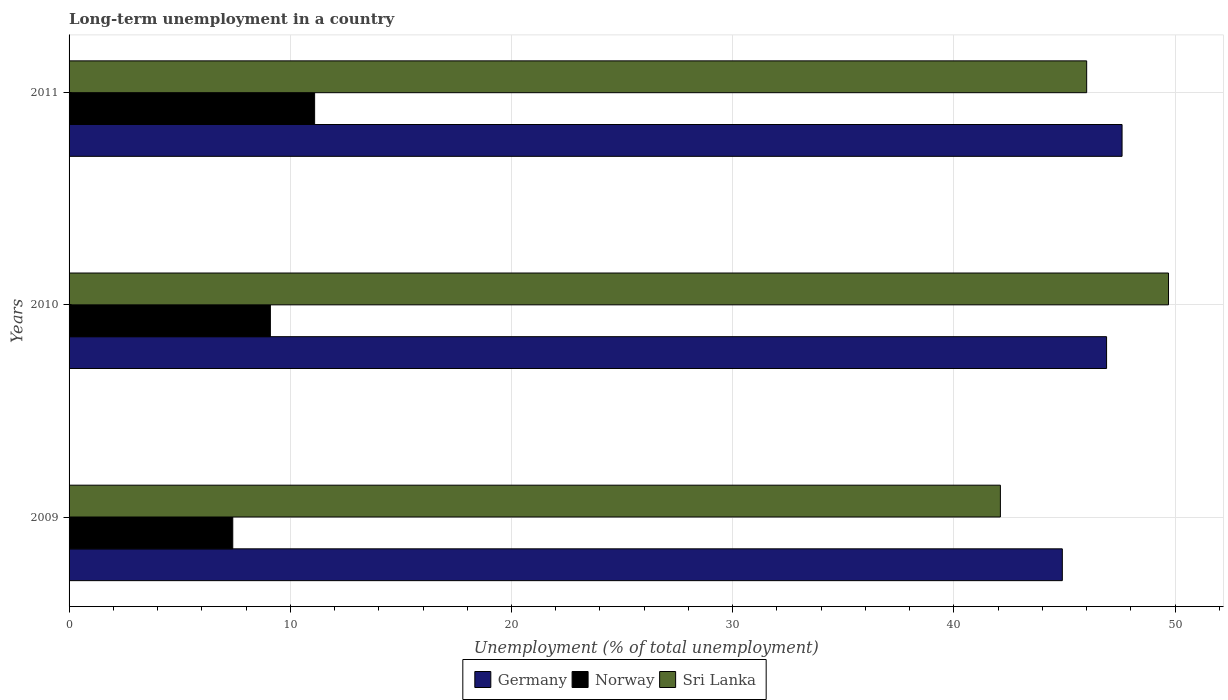How many groups of bars are there?
Provide a short and direct response. 3. Are the number of bars per tick equal to the number of legend labels?
Offer a terse response. Yes. Are the number of bars on each tick of the Y-axis equal?
Keep it short and to the point. Yes. How many bars are there on the 2nd tick from the top?
Keep it short and to the point. 3. How many bars are there on the 1st tick from the bottom?
Your response must be concise. 3. What is the label of the 1st group of bars from the top?
Provide a succinct answer. 2011. In how many cases, is the number of bars for a given year not equal to the number of legend labels?
Ensure brevity in your answer.  0. What is the percentage of long-term unemployed population in Germany in 2009?
Make the answer very short. 44.9. Across all years, what is the maximum percentage of long-term unemployed population in Sri Lanka?
Keep it short and to the point. 49.7. Across all years, what is the minimum percentage of long-term unemployed population in Germany?
Make the answer very short. 44.9. In which year was the percentage of long-term unemployed population in Norway minimum?
Ensure brevity in your answer.  2009. What is the total percentage of long-term unemployed population in Germany in the graph?
Provide a succinct answer. 139.4. What is the difference between the percentage of long-term unemployed population in Sri Lanka in 2009 and that in 2010?
Ensure brevity in your answer.  -7.6. What is the difference between the percentage of long-term unemployed population in Germany in 2010 and the percentage of long-term unemployed population in Norway in 2011?
Your answer should be very brief. 35.8. What is the average percentage of long-term unemployed population in Germany per year?
Provide a succinct answer. 46.47. In the year 2009, what is the difference between the percentage of long-term unemployed population in Sri Lanka and percentage of long-term unemployed population in Norway?
Your response must be concise. 34.7. In how many years, is the percentage of long-term unemployed population in Germany greater than 8 %?
Your answer should be very brief. 3. What is the ratio of the percentage of long-term unemployed population in Norway in 2010 to that in 2011?
Keep it short and to the point. 0.82. Is the difference between the percentage of long-term unemployed population in Sri Lanka in 2009 and 2011 greater than the difference between the percentage of long-term unemployed population in Norway in 2009 and 2011?
Offer a terse response. No. What is the difference between the highest and the second highest percentage of long-term unemployed population in Sri Lanka?
Ensure brevity in your answer.  3.7. What is the difference between the highest and the lowest percentage of long-term unemployed population in Germany?
Ensure brevity in your answer.  2.7. In how many years, is the percentage of long-term unemployed population in Norway greater than the average percentage of long-term unemployed population in Norway taken over all years?
Provide a succinct answer. 1. What does the 1st bar from the bottom in 2009 represents?
Provide a short and direct response. Germany. How many years are there in the graph?
Offer a very short reply. 3. Are the values on the major ticks of X-axis written in scientific E-notation?
Your answer should be very brief. No. Does the graph contain any zero values?
Offer a very short reply. No. Where does the legend appear in the graph?
Your answer should be compact. Bottom center. How many legend labels are there?
Keep it short and to the point. 3. What is the title of the graph?
Your answer should be compact. Long-term unemployment in a country. What is the label or title of the X-axis?
Ensure brevity in your answer.  Unemployment (% of total unemployment). What is the Unemployment (% of total unemployment) in Germany in 2009?
Offer a terse response. 44.9. What is the Unemployment (% of total unemployment) of Norway in 2009?
Make the answer very short. 7.4. What is the Unemployment (% of total unemployment) in Sri Lanka in 2009?
Make the answer very short. 42.1. What is the Unemployment (% of total unemployment) of Germany in 2010?
Your response must be concise. 46.9. What is the Unemployment (% of total unemployment) of Norway in 2010?
Provide a succinct answer. 9.1. What is the Unemployment (% of total unemployment) in Sri Lanka in 2010?
Provide a succinct answer. 49.7. What is the Unemployment (% of total unemployment) of Germany in 2011?
Your answer should be compact. 47.6. What is the Unemployment (% of total unemployment) in Norway in 2011?
Make the answer very short. 11.1. What is the Unemployment (% of total unemployment) in Sri Lanka in 2011?
Keep it short and to the point. 46. Across all years, what is the maximum Unemployment (% of total unemployment) in Germany?
Provide a succinct answer. 47.6. Across all years, what is the maximum Unemployment (% of total unemployment) of Norway?
Provide a short and direct response. 11.1. Across all years, what is the maximum Unemployment (% of total unemployment) of Sri Lanka?
Your answer should be very brief. 49.7. Across all years, what is the minimum Unemployment (% of total unemployment) of Germany?
Ensure brevity in your answer.  44.9. Across all years, what is the minimum Unemployment (% of total unemployment) in Norway?
Offer a very short reply. 7.4. Across all years, what is the minimum Unemployment (% of total unemployment) of Sri Lanka?
Keep it short and to the point. 42.1. What is the total Unemployment (% of total unemployment) of Germany in the graph?
Offer a terse response. 139.4. What is the total Unemployment (% of total unemployment) of Norway in the graph?
Make the answer very short. 27.6. What is the total Unemployment (% of total unemployment) of Sri Lanka in the graph?
Keep it short and to the point. 137.8. What is the difference between the Unemployment (% of total unemployment) of Norway in 2009 and that in 2010?
Your response must be concise. -1.7. What is the difference between the Unemployment (% of total unemployment) in Sri Lanka in 2010 and that in 2011?
Keep it short and to the point. 3.7. What is the difference between the Unemployment (% of total unemployment) in Germany in 2009 and the Unemployment (% of total unemployment) in Norway in 2010?
Offer a very short reply. 35.8. What is the difference between the Unemployment (% of total unemployment) of Norway in 2009 and the Unemployment (% of total unemployment) of Sri Lanka in 2010?
Provide a succinct answer. -42.3. What is the difference between the Unemployment (% of total unemployment) of Germany in 2009 and the Unemployment (% of total unemployment) of Norway in 2011?
Provide a short and direct response. 33.8. What is the difference between the Unemployment (% of total unemployment) in Norway in 2009 and the Unemployment (% of total unemployment) in Sri Lanka in 2011?
Ensure brevity in your answer.  -38.6. What is the difference between the Unemployment (% of total unemployment) of Germany in 2010 and the Unemployment (% of total unemployment) of Norway in 2011?
Provide a succinct answer. 35.8. What is the difference between the Unemployment (% of total unemployment) in Norway in 2010 and the Unemployment (% of total unemployment) in Sri Lanka in 2011?
Give a very brief answer. -36.9. What is the average Unemployment (% of total unemployment) in Germany per year?
Offer a terse response. 46.47. What is the average Unemployment (% of total unemployment) in Sri Lanka per year?
Your response must be concise. 45.93. In the year 2009, what is the difference between the Unemployment (% of total unemployment) of Germany and Unemployment (% of total unemployment) of Norway?
Ensure brevity in your answer.  37.5. In the year 2009, what is the difference between the Unemployment (% of total unemployment) in Norway and Unemployment (% of total unemployment) in Sri Lanka?
Your answer should be very brief. -34.7. In the year 2010, what is the difference between the Unemployment (% of total unemployment) in Germany and Unemployment (% of total unemployment) in Norway?
Keep it short and to the point. 37.8. In the year 2010, what is the difference between the Unemployment (% of total unemployment) in Germany and Unemployment (% of total unemployment) in Sri Lanka?
Give a very brief answer. -2.8. In the year 2010, what is the difference between the Unemployment (% of total unemployment) of Norway and Unemployment (% of total unemployment) of Sri Lanka?
Your answer should be very brief. -40.6. In the year 2011, what is the difference between the Unemployment (% of total unemployment) in Germany and Unemployment (% of total unemployment) in Norway?
Keep it short and to the point. 36.5. In the year 2011, what is the difference between the Unemployment (% of total unemployment) of Germany and Unemployment (% of total unemployment) of Sri Lanka?
Provide a succinct answer. 1.6. In the year 2011, what is the difference between the Unemployment (% of total unemployment) in Norway and Unemployment (% of total unemployment) in Sri Lanka?
Make the answer very short. -34.9. What is the ratio of the Unemployment (% of total unemployment) in Germany in 2009 to that in 2010?
Your response must be concise. 0.96. What is the ratio of the Unemployment (% of total unemployment) in Norway in 2009 to that in 2010?
Your answer should be compact. 0.81. What is the ratio of the Unemployment (% of total unemployment) of Sri Lanka in 2009 to that in 2010?
Provide a succinct answer. 0.85. What is the ratio of the Unemployment (% of total unemployment) in Germany in 2009 to that in 2011?
Provide a succinct answer. 0.94. What is the ratio of the Unemployment (% of total unemployment) of Sri Lanka in 2009 to that in 2011?
Ensure brevity in your answer.  0.92. What is the ratio of the Unemployment (% of total unemployment) of Norway in 2010 to that in 2011?
Make the answer very short. 0.82. What is the ratio of the Unemployment (% of total unemployment) in Sri Lanka in 2010 to that in 2011?
Your answer should be very brief. 1.08. What is the difference between the highest and the second highest Unemployment (% of total unemployment) of Germany?
Offer a terse response. 0.7. What is the difference between the highest and the second highest Unemployment (% of total unemployment) in Norway?
Offer a terse response. 2. What is the difference between the highest and the second highest Unemployment (% of total unemployment) in Sri Lanka?
Provide a short and direct response. 3.7. What is the difference between the highest and the lowest Unemployment (% of total unemployment) in Germany?
Provide a succinct answer. 2.7. 